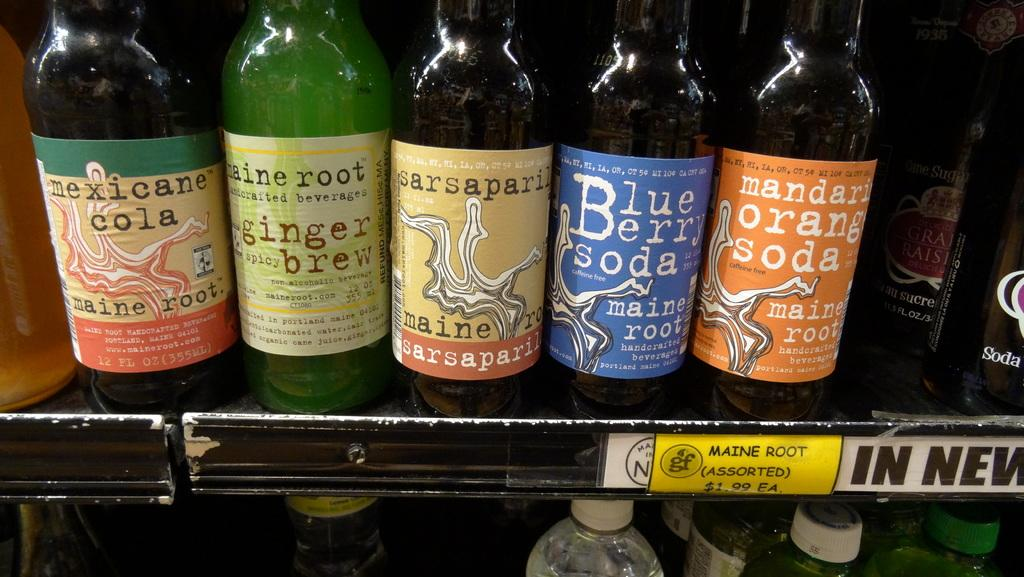Provide a one-sentence caption for the provided image. Five bottles of soda, one of which is mandarin orange. 